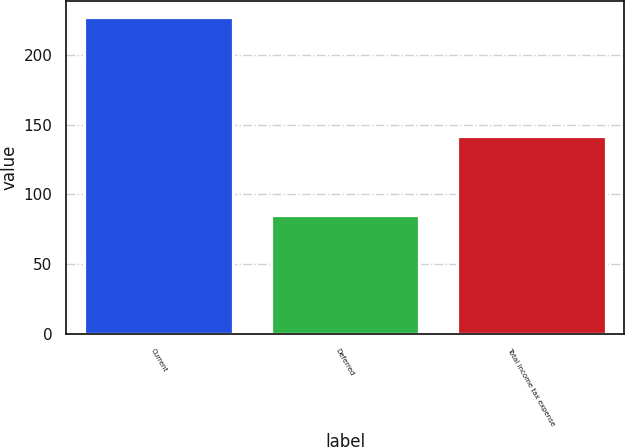<chart> <loc_0><loc_0><loc_500><loc_500><bar_chart><fcel>Current<fcel>Deferred<fcel>Total income tax expense<nl><fcel>227<fcel>85<fcel>142<nl></chart> 